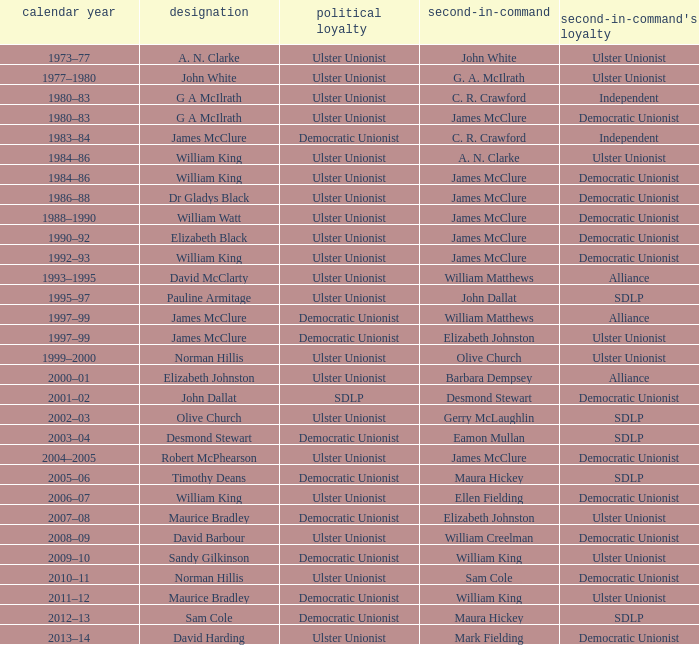What is the name of the Deputy when the Name was elizabeth black? James McClure. 